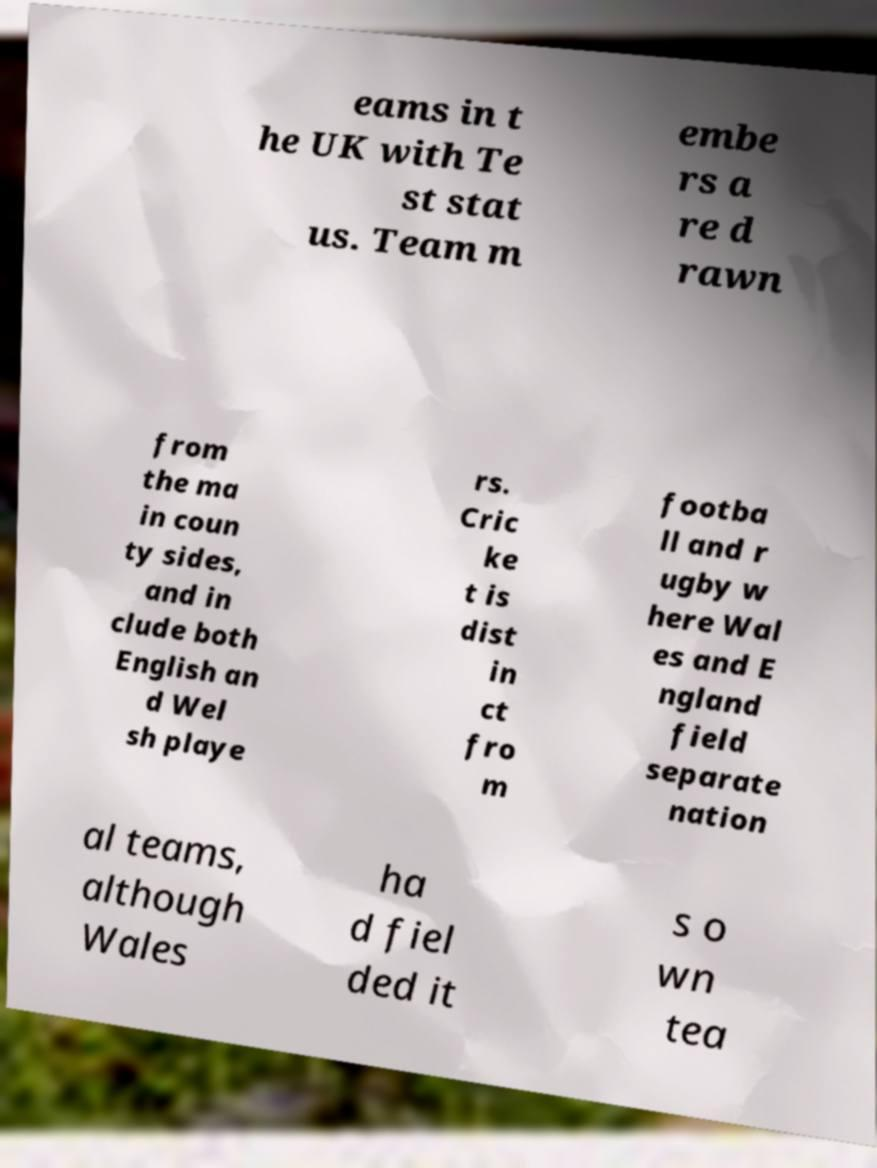Can you read and provide the text displayed in the image?This photo seems to have some interesting text. Can you extract and type it out for me? eams in t he UK with Te st stat us. Team m embe rs a re d rawn from the ma in coun ty sides, and in clude both English an d Wel sh playe rs. Cric ke t is dist in ct fro m footba ll and r ugby w here Wal es and E ngland field separate nation al teams, although Wales ha d fiel ded it s o wn tea 